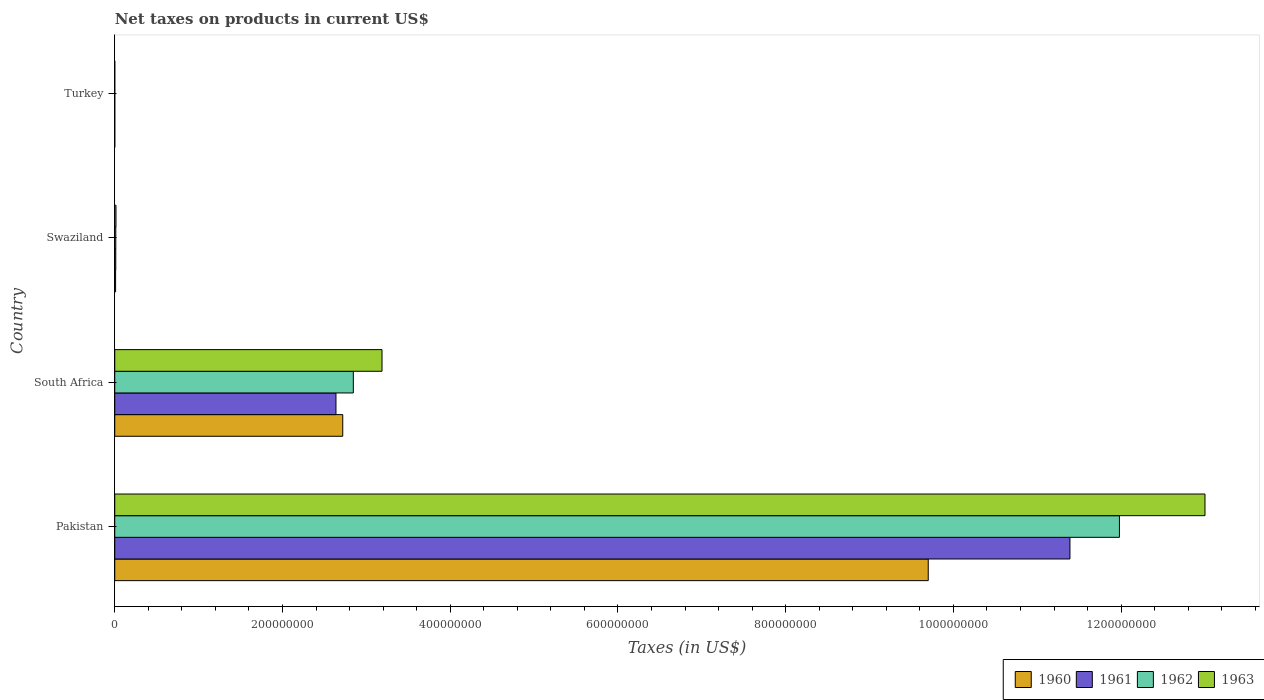How many different coloured bars are there?
Your answer should be compact. 4. Are the number of bars on each tick of the Y-axis equal?
Give a very brief answer. Yes. How many bars are there on the 4th tick from the top?
Your answer should be compact. 4. How many bars are there on the 3rd tick from the bottom?
Your answer should be compact. 4. What is the label of the 2nd group of bars from the top?
Keep it short and to the point. Swaziland. What is the net taxes on products in 1963 in Turkey?
Offer a terse response. 1800. Across all countries, what is the maximum net taxes on products in 1962?
Keep it short and to the point. 1.20e+09. Across all countries, what is the minimum net taxes on products in 1963?
Your response must be concise. 1800. What is the total net taxes on products in 1960 in the graph?
Your answer should be very brief. 1.24e+09. What is the difference between the net taxes on products in 1963 in Pakistan and that in Swaziland?
Your answer should be compact. 1.30e+09. What is the difference between the net taxes on products in 1961 in South Africa and the net taxes on products in 1962 in Pakistan?
Your response must be concise. -9.34e+08. What is the average net taxes on products in 1960 per country?
Offer a very short reply. 3.11e+08. What is the difference between the net taxes on products in 1960 and net taxes on products in 1963 in Pakistan?
Offer a very short reply. -3.30e+08. What is the ratio of the net taxes on products in 1961 in South Africa to that in Turkey?
Ensure brevity in your answer.  1.76e+05. Is the difference between the net taxes on products in 1960 in South Africa and Turkey greater than the difference between the net taxes on products in 1963 in South Africa and Turkey?
Your response must be concise. No. What is the difference between the highest and the second highest net taxes on products in 1960?
Provide a succinct answer. 6.98e+08. What is the difference between the highest and the lowest net taxes on products in 1960?
Offer a terse response. 9.70e+08. Is the sum of the net taxes on products in 1962 in Pakistan and South Africa greater than the maximum net taxes on products in 1963 across all countries?
Provide a succinct answer. Yes. Is it the case that in every country, the sum of the net taxes on products in 1960 and net taxes on products in 1963 is greater than the sum of net taxes on products in 1961 and net taxes on products in 1962?
Offer a terse response. No. Is it the case that in every country, the sum of the net taxes on products in 1962 and net taxes on products in 1963 is greater than the net taxes on products in 1960?
Make the answer very short. Yes. Are all the bars in the graph horizontal?
Offer a very short reply. Yes. How many countries are there in the graph?
Offer a terse response. 4. How are the legend labels stacked?
Keep it short and to the point. Horizontal. What is the title of the graph?
Give a very brief answer. Net taxes on products in current US$. Does "1966" appear as one of the legend labels in the graph?
Offer a terse response. No. What is the label or title of the X-axis?
Offer a terse response. Taxes (in US$). What is the Taxes (in US$) of 1960 in Pakistan?
Your answer should be compact. 9.70e+08. What is the Taxes (in US$) of 1961 in Pakistan?
Offer a very short reply. 1.14e+09. What is the Taxes (in US$) in 1962 in Pakistan?
Offer a very short reply. 1.20e+09. What is the Taxes (in US$) of 1963 in Pakistan?
Your answer should be compact. 1.30e+09. What is the Taxes (in US$) in 1960 in South Africa?
Your answer should be compact. 2.72e+08. What is the Taxes (in US$) of 1961 in South Africa?
Make the answer very short. 2.64e+08. What is the Taxes (in US$) in 1962 in South Africa?
Provide a succinct answer. 2.84e+08. What is the Taxes (in US$) of 1963 in South Africa?
Offer a terse response. 3.19e+08. What is the Taxes (in US$) in 1960 in Swaziland?
Ensure brevity in your answer.  1.00e+06. What is the Taxes (in US$) in 1961 in Swaziland?
Give a very brief answer. 1.21e+06. What is the Taxes (in US$) of 1962 in Swaziland?
Your response must be concise. 1.24e+06. What is the Taxes (in US$) in 1963 in Swaziland?
Provide a succinct answer. 1.47e+06. What is the Taxes (in US$) in 1960 in Turkey?
Ensure brevity in your answer.  1300. What is the Taxes (in US$) in 1961 in Turkey?
Make the answer very short. 1500. What is the Taxes (in US$) of 1962 in Turkey?
Your answer should be compact. 1600. What is the Taxes (in US$) in 1963 in Turkey?
Make the answer very short. 1800. Across all countries, what is the maximum Taxes (in US$) of 1960?
Provide a succinct answer. 9.70e+08. Across all countries, what is the maximum Taxes (in US$) of 1961?
Your answer should be compact. 1.14e+09. Across all countries, what is the maximum Taxes (in US$) of 1962?
Provide a succinct answer. 1.20e+09. Across all countries, what is the maximum Taxes (in US$) of 1963?
Offer a terse response. 1.30e+09. Across all countries, what is the minimum Taxes (in US$) of 1960?
Your response must be concise. 1300. Across all countries, what is the minimum Taxes (in US$) in 1961?
Your answer should be very brief. 1500. Across all countries, what is the minimum Taxes (in US$) in 1962?
Ensure brevity in your answer.  1600. Across all countries, what is the minimum Taxes (in US$) in 1963?
Make the answer very short. 1800. What is the total Taxes (in US$) of 1960 in the graph?
Provide a succinct answer. 1.24e+09. What is the total Taxes (in US$) of 1961 in the graph?
Give a very brief answer. 1.40e+09. What is the total Taxes (in US$) in 1962 in the graph?
Your answer should be compact. 1.48e+09. What is the total Taxes (in US$) of 1963 in the graph?
Your answer should be compact. 1.62e+09. What is the difference between the Taxes (in US$) of 1960 in Pakistan and that in South Africa?
Offer a very short reply. 6.98e+08. What is the difference between the Taxes (in US$) of 1961 in Pakistan and that in South Africa?
Your answer should be very brief. 8.75e+08. What is the difference between the Taxes (in US$) of 1962 in Pakistan and that in South Africa?
Ensure brevity in your answer.  9.14e+08. What is the difference between the Taxes (in US$) of 1963 in Pakistan and that in South Africa?
Your response must be concise. 9.81e+08. What is the difference between the Taxes (in US$) of 1960 in Pakistan and that in Swaziland?
Ensure brevity in your answer.  9.69e+08. What is the difference between the Taxes (in US$) in 1961 in Pakistan and that in Swaziland?
Your answer should be very brief. 1.14e+09. What is the difference between the Taxes (in US$) of 1962 in Pakistan and that in Swaziland?
Make the answer very short. 1.20e+09. What is the difference between the Taxes (in US$) of 1963 in Pakistan and that in Swaziland?
Your answer should be compact. 1.30e+09. What is the difference between the Taxes (in US$) of 1960 in Pakistan and that in Turkey?
Your answer should be compact. 9.70e+08. What is the difference between the Taxes (in US$) of 1961 in Pakistan and that in Turkey?
Your answer should be compact. 1.14e+09. What is the difference between the Taxes (in US$) of 1962 in Pakistan and that in Turkey?
Make the answer very short. 1.20e+09. What is the difference between the Taxes (in US$) of 1963 in Pakistan and that in Turkey?
Provide a succinct answer. 1.30e+09. What is the difference between the Taxes (in US$) in 1960 in South Africa and that in Swaziland?
Give a very brief answer. 2.71e+08. What is the difference between the Taxes (in US$) of 1961 in South Africa and that in Swaziland?
Keep it short and to the point. 2.63e+08. What is the difference between the Taxes (in US$) in 1962 in South Africa and that in Swaziland?
Make the answer very short. 2.83e+08. What is the difference between the Taxes (in US$) of 1963 in South Africa and that in Swaziland?
Provide a short and direct response. 3.17e+08. What is the difference between the Taxes (in US$) in 1960 in South Africa and that in Turkey?
Offer a very short reply. 2.72e+08. What is the difference between the Taxes (in US$) of 1961 in South Africa and that in Turkey?
Your answer should be very brief. 2.64e+08. What is the difference between the Taxes (in US$) of 1962 in South Africa and that in Turkey?
Give a very brief answer. 2.84e+08. What is the difference between the Taxes (in US$) in 1963 in South Africa and that in Turkey?
Provide a short and direct response. 3.19e+08. What is the difference between the Taxes (in US$) of 1960 in Swaziland and that in Turkey?
Your answer should be compact. 1.00e+06. What is the difference between the Taxes (in US$) of 1961 in Swaziland and that in Turkey?
Give a very brief answer. 1.21e+06. What is the difference between the Taxes (in US$) in 1962 in Swaziland and that in Turkey?
Your answer should be very brief. 1.24e+06. What is the difference between the Taxes (in US$) in 1963 in Swaziland and that in Turkey?
Give a very brief answer. 1.47e+06. What is the difference between the Taxes (in US$) of 1960 in Pakistan and the Taxes (in US$) of 1961 in South Africa?
Make the answer very short. 7.06e+08. What is the difference between the Taxes (in US$) in 1960 in Pakistan and the Taxes (in US$) in 1962 in South Africa?
Provide a succinct answer. 6.86e+08. What is the difference between the Taxes (in US$) in 1960 in Pakistan and the Taxes (in US$) in 1963 in South Africa?
Provide a short and direct response. 6.51e+08. What is the difference between the Taxes (in US$) of 1961 in Pakistan and the Taxes (in US$) of 1962 in South Africa?
Ensure brevity in your answer.  8.55e+08. What is the difference between the Taxes (in US$) of 1961 in Pakistan and the Taxes (in US$) of 1963 in South Africa?
Ensure brevity in your answer.  8.20e+08. What is the difference between the Taxes (in US$) in 1962 in Pakistan and the Taxes (in US$) in 1963 in South Africa?
Provide a short and direct response. 8.79e+08. What is the difference between the Taxes (in US$) in 1960 in Pakistan and the Taxes (in US$) in 1961 in Swaziland?
Provide a short and direct response. 9.69e+08. What is the difference between the Taxes (in US$) of 1960 in Pakistan and the Taxes (in US$) of 1962 in Swaziland?
Keep it short and to the point. 9.69e+08. What is the difference between the Taxes (in US$) of 1960 in Pakistan and the Taxes (in US$) of 1963 in Swaziland?
Your answer should be compact. 9.69e+08. What is the difference between the Taxes (in US$) in 1961 in Pakistan and the Taxes (in US$) in 1962 in Swaziland?
Your answer should be very brief. 1.14e+09. What is the difference between the Taxes (in US$) of 1961 in Pakistan and the Taxes (in US$) of 1963 in Swaziland?
Keep it short and to the point. 1.14e+09. What is the difference between the Taxes (in US$) of 1962 in Pakistan and the Taxes (in US$) of 1963 in Swaziland?
Offer a terse response. 1.20e+09. What is the difference between the Taxes (in US$) in 1960 in Pakistan and the Taxes (in US$) in 1961 in Turkey?
Make the answer very short. 9.70e+08. What is the difference between the Taxes (in US$) in 1960 in Pakistan and the Taxes (in US$) in 1962 in Turkey?
Your answer should be compact. 9.70e+08. What is the difference between the Taxes (in US$) of 1960 in Pakistan and the Taxes (in US$) of 1963 in Turkey?
Offer a terse response. 9.70e+08. What is the difference between the Taxes (in US$) in 1961 in Pakistan and the Taxes (in US$) in 1962 in Turkey?
Provide a succinct answer. 1.14e+09. What is the difference between the Taxes (in US$) in 1961 in Pakistan and the Taxes (in US$) in 1963 in Turkey?
Offer a terse response. 1.14e+09. What is the difference between the Taxes (in US$) in 1962 in Pakistan and the Taxes (in US$) in 1963 in Turkey?
Ensure brevity in your answer.  1.20e+09. What is the difference between the Taxes (in US$) of 1960 in South Africa and the Taxes (in US$) of 1961 in Swaziland?
Your answer should be compact. 2.71e+08. What is the difference between the Taxes (in US$) of 1960 in South Africa and the Taxes (in US$) of 1962 in Swaziland?
Ensure brevity in your answer.  2.71e+08. What is the difference between the Taxes (in US$) of 1960 in South Africa and the Taxes (in US$) of 1963 in Swaziland?
Give a very brief answer. 2.70e+08. What is the difference between the Taxes (in US$) of 1961 in South Africa and the Taxes (in US$) of 1962 in Swaziland?
Keep it short and to the point. 2.63e+08. What is the difference between the Taxes (in US$) in 1961 in South Africa and the Taxes (in US$) in 1963 in Swaziland?
Provide a succinct answer. 2.62e+08. What is the difference between the Taxes (in US$) of 1962 in South Africa and the Taxes (in US$) of 1963 in Swaziland?
Keep it short and to the point. 2.83e+08. What is the difference between the Taxes (in US$) of 1960 in South Africa and the Taxes (in US$) of 1961 in Turkey?
Offer a terse response. 2.72e+08. What is the difference between the Taxes (in US$) in 1960 in South Africa and the Taxes (in US$) in 1962 in Turkey?
Your response must be concise. 2.72e+08. What is the difference between the Taxes (in US$) of 1960 in South Africa and the Taxes (in US$) of 1963 in Turkey?
Ensure brevity in your answer.  2.72e+08. What is the difference between the Taxes (in US$) of 1961 in South Africa and the Taxes (in US$) of 1962 in Turkey?
Your answer should be very brief. 2.64e+08. What is the difference between the Taxes (in US$) in 1961 in South Africa and the Taxes (in US$) in 1963 in Turkey?
Give a very brief answer. 2.64e+08. What is the difference between the Taxes (in US$) in 1962 in South Africa and the Taxes (in US$) in 1963 in Turkey?
Your response must be concise. 2.84e+08. What is the difference between the Taxes (in US$) of 1960 in Swaziland and the Taxes (in US$) of 1961 in Turkey?
Offer a terse response. 1.00e+06. What is the difference between the Taxes (in US$) in 1960 in Swaziland and the Taxes (in US$) in 1962 in Turkey?
Your response must be concise. 1.00e+06. What is the difference between the Taxes (in US$) in 1960 in Swaziland and the Taxes (in US$) in 1963 in Turkey?
Make the answer very short. 1.00e+06. What is the difference between the Taxes (in US$) of 1961 in Swaziland and the Taxes (in US$) of 1962 in Turkey?
Provide a short and direct response. 1.21e+06. What is the difference between the Taxes (in US$) of 1961 in Swaziland and the Taxes (in US$) of 1963 in Turkey?
Offer a very short reply. 1.21e+06. What is the difference between the Taxes (in US$) in 1962 in Swaziland and the Taxes (in US$) in 1963 in Turkey?
Offer a terse response. 1.24e+06. What is the average Taxes (in US$) of 1960 per country?
Your response must be concise. 3.11e+08. What is the average Taxes (in US$) of 1961 per country?
Provide a short and direct response. 3.51e+08. What is the average Taxes (in US$) in 1962 per country?
Offer a very short reply. 3.71e+08. What is the average Taxes (in US$) of 1963 per country?
Keep it short and to the point. 4.05e+08. What is the difference between the Taxes (in US$) in 1960 and Taxes (in US$) in 1961 in Pakistan?
Provide a succinct answer. -1.69e+08. What is the difference between the Taxes (in US$) of 1960 and Taxes (in US$) of 1962 in Pakistan?
Make the answer very short. -2.28e+08. What is the difference between the Taxes (in US$) in 1960 and Taxes (in US$) in 1963 in Pakistan?
Your answer should be very brief. -3.30e+08. What is the difference between the Taxes (in US$) in 1961 and Taxes (in US$) in 1962 in Pakistan?
Provide a succinct answer. -5.90e+07. What is the difference between the Taxes (in US$) in 1961 and Taxes (in US$) in 1963 in Pakistan?
Provide a succinct answer. -1.61e+08. What is the difference between the Taxes (in US$) of 1962 and Taxes (in US$) of 1963 in Pakistan?
Offer a terse response. -1.02e+08. What is the difference between the Taxes (in US$) in 1960 and Taxes (in US$) in 1961 in South Africa?
Give a very brief answer. 8.10e+06. What is the difference between the Taxes (in US$) of 1960 and Taxes (in US$) of 1962 in South Africa?
Your answer should be very brief. -1.26e+07. What is the difference between the Taxes (in US$) in 1960 and Taxes (in US$) in 1963 in South Africa?
Your answer should be very brief. -4.68e+07. What is the difference between the Taxes (in US$) of 1961 and Taxes (in US$) of 1962 in South Africa?
Make the answer very short. -2.07e+07. What is the difference between the Taxes (in US$) of 1961 and Taxes (in US$) of 1963 in South Africa?
Offer a very short reply. -5.49e+07. What is the difference between the Taxes (in US$) of 1962 and Taxes (in US$) of 1963 in South Africa?
Offer a very short reply. -3.42e+07. What is the difference between the Taxes (in US$) of 1960 and Taxes (in US$) of 1961 in Swaziland?
Offer a terse response. -2.06e+05. What is the difference between the Taxes (in US$) in 1960 and Taxes (in US$) in 1962 in Swaziland?
Your answer should be very brief. -2.36e+05. What is the difference between the Taxes (in US$) in 1960 and Taxes (in US$) in 1963 in Swaziland?
Ensure brevity in your answer.  -4.72e+05. What is the difference between the Taxes (in US$) of 1961 and Taxes (in US$) of 1962 in Swaziland?
Ensure brevity in your answer.  -2.95e+04. What is the difference between the Taxes (in US$) in 1961 and Taxes (in US$) in 1963 in Swaziland?
Offer a terse response. -2.65e+05. What is the difference between the Taxes (in US$) in 1962 and Taxes (in US$) in 1963 in Swaziland?
Make the answer very short. -2.36e+05. What is the difference between the Taxes (in US$) in 1960 and Taxes (in US$) in 1961 in Turkey?
Offer a very short reply. -200. What is the difference between the Taxes (in US$) in 1960 and Taxes (in US$) in 1962 in Turkey?
Provide a short and direct response. -300. What is the difference between the Taxes (in US$) of 1960 and Taxes (in US$) of 1963 in Turkey?
Your answer should be compact. -500. What is the difference between the Taxes (in US$) in 1961 and Taxes (in US$) in 1962 in Turkey?
Offer a very short reply. -100. What is the difference between the Taxes (in US$) in 1961 and Taxes (in US$) in 1963 in Turkey?
Give a very brief answer. -300. What is the difference between the Taxes (in US$) of 1962 and Taxes (in US$) of 1963 in Turkey?
Make the answer very short. -200. What is the ratio of the Taxes (in US$) of 1960 in Pakistan to that in South Africa?
Give a very brief answer. 3.57. What is the ratio of the Taxes (in US$) of 1961 in Pakistan to that in South Africa?
Offer a terse response. 4.32. What is the ratio of the Taxes (in US$) in 1962 in Pakistan to that in South Africa?
Offer a very short reply. 4.21. What is the ratio of the Taxes (in US$) of 1963 in Pakistan to that in South Africa?
Offer a very short reply. 4.08. What is the ratio of the Taxes (in US$) in 1960 in Pakistan to that in Swaziland?
Your answer should be compact. 967.48. What is the ratio of the Taxes (in US$) of 1961 in Pakistan to that in Swaziland?
Give a very brief answer. 942.1. What is the ratio of the Taxes (in US$) in 1962 in Pakistan to that in Swaziland?
Your response must be concise. 967.3. What is the ratio of the Taxes (in US$) in 1963 in Pakistan to that in Swaziland?
Your answer should be compact. 881.71. What is the ratio of the Taxes (in US$) of 1960 in Pakistan to that in Turkey?
Make the answer very short. 7.46e+05. What is the ratio of the Taxes (in US$) of 1961 in Pakistan to that in Turkey?
Your response must be concise. 7.59e+05. What is the ratio of the Taxes (in US$) in 1962 in Pakistan to that in Turkey?
Your answer should be very brief. 7.49e+05. What is the ratio of the Taxes (in US$) of 1963 in Pakistan to that in Turkey?
Make the answer very short. 7.22e+05. What is the ratio of the Taxes (in US$) in 1960 in South Africa to that in Swaziland?
Offer a terse response. 271.17. What is the ratio of the Taxes (in US$) in 1961 in South Africa to that in Swaziland?
Give a very brief answer. 218.17. What is the ratio of the Taxes (in US$) in 1962 in South Africa to that in Swaziland?
Ensure brevity in your answer.  229.69. What is the ratio of the Taxes (in US$) in 1963 in South Africa to that in Swaziland?
Your answer should be compact. 216.15. What is the ratio of the Taxes (in US$) in 1960 in South Africa to that in Turkey?
Keep it short and to the point. 2.09e+05. What is the ratio of the Taxes (in US$) in 1961 in South Africa to that in Turkey?
Keep it short and to the point. 1.76e+05. What is the ratio of the Taxes (in US$) in 1962 in South Africa to that in Turkey?
Ensure brevity in your answer.  1.78e+05. What is the ratio of the Taxes (in US$) of 1963 in South Africa to that in Turkey?
Offer a terse response. 1.77e+05. What is the ratio of the Taxes (in US$) in 1960 in Swaziland to that in Turkey?
Your response must be concise. 771.23. What is the ratio of the Taxes (in US$) in 1961 in Swaziland to that in Turkey?
Your response must be concise. 806. What is the ratio of the Taxes (in US$) of 1962 in Swaziland to that in Turkey?
Your answer should be very brief. 774.06. What is the ratio of the Taxes (in US$) in 1963 in Swaziland to that in Turkey?
Your response must be concise. 819.11. What is the difference between the highest and the second highest Taxes (in US$) of 1960?
Give a very brief answer. 6.98e+08. What is the difference between the highest and the second highest Taxes (in US$) in 1961?
Ensure brevity in your answer.  8.75e+08. What is the difference between the highest and the second highest Taxes (in US$) in 1962?
Your answer should be very brief. 9.14e+08. What is the difference between the highest and the second highest Taxes (in US$) of 1963?
Provide a short and direct response. 9.81e+08. What is the difference between the highest and the lowest Taxes (in US$) of 1960?
Give a very brief answer. 9.70e+08. What is the difference between the highest and the lowest Taxes (in US$) of 1961?
Provide a succinct answer. 1.14e+09. What is the difference between the highest and the lowest Taxes (in US$) of 1962?
Ensure brevity in your answer.  1.20e+09. What is the difference between the highest and the lowest Taxes (in US$) in 1963?
Provide a succinct answer. 1.30e+09. 